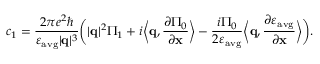Convert formula to latex. <formula><loc_0><loc_0><loc_500><loc_500>c _ { 1 } = \frac { 2 \pi e ^ { 2 } } { \varepsilon _ { a v g } | q | ^ { 3 } } \left ( | q | ^ { 2 } \Pi _ { 1 } + i \left \langle q , \frac { \partial \Pi _ { 0 } } { \partial x } \right \rangle - \frac { i \Pi _ { 0 } } { 2 \varepsilon _ { a v g } } \left \langle q , \frac { \partial \varepsilon _ { a v g } } { \partial x } \right \rangle \right ) .</formula> 